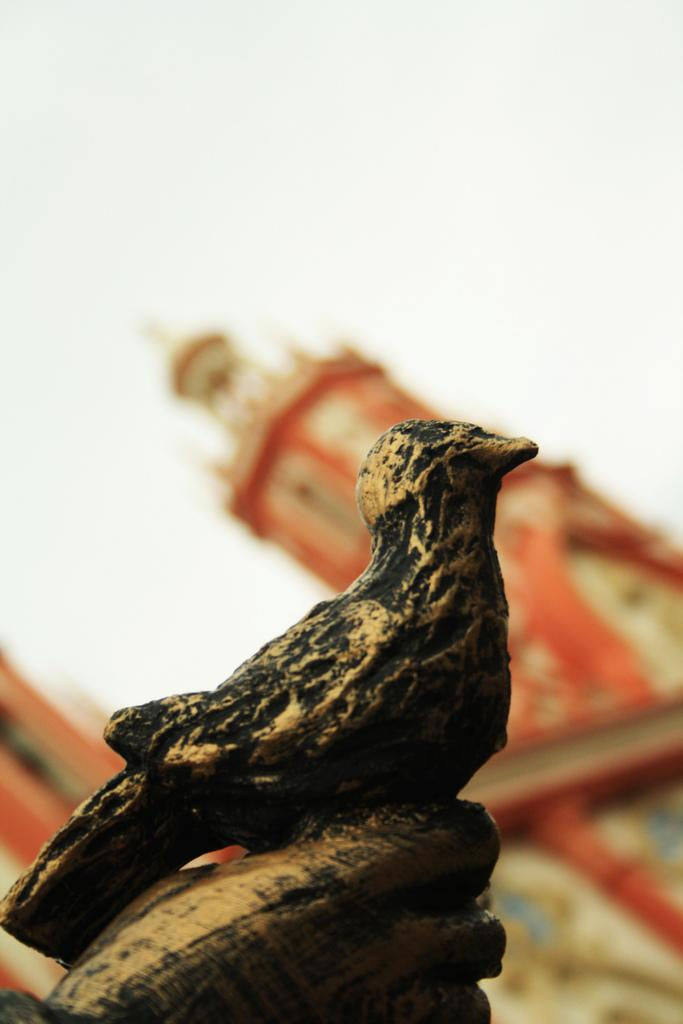What is the main subject in the center of the image? There is a statue in the center of the image. What can be seen in the background of the image? There is a building in the background of the image. What is visible at the top of the image? The sky is visible at the top of the image. What type of shoes can be seen on the statue in the image? There are no shoes visible on the statue in the image. What activity is the statue participating in within the image? The statue is not participating in any activity; it is a stationary object. 